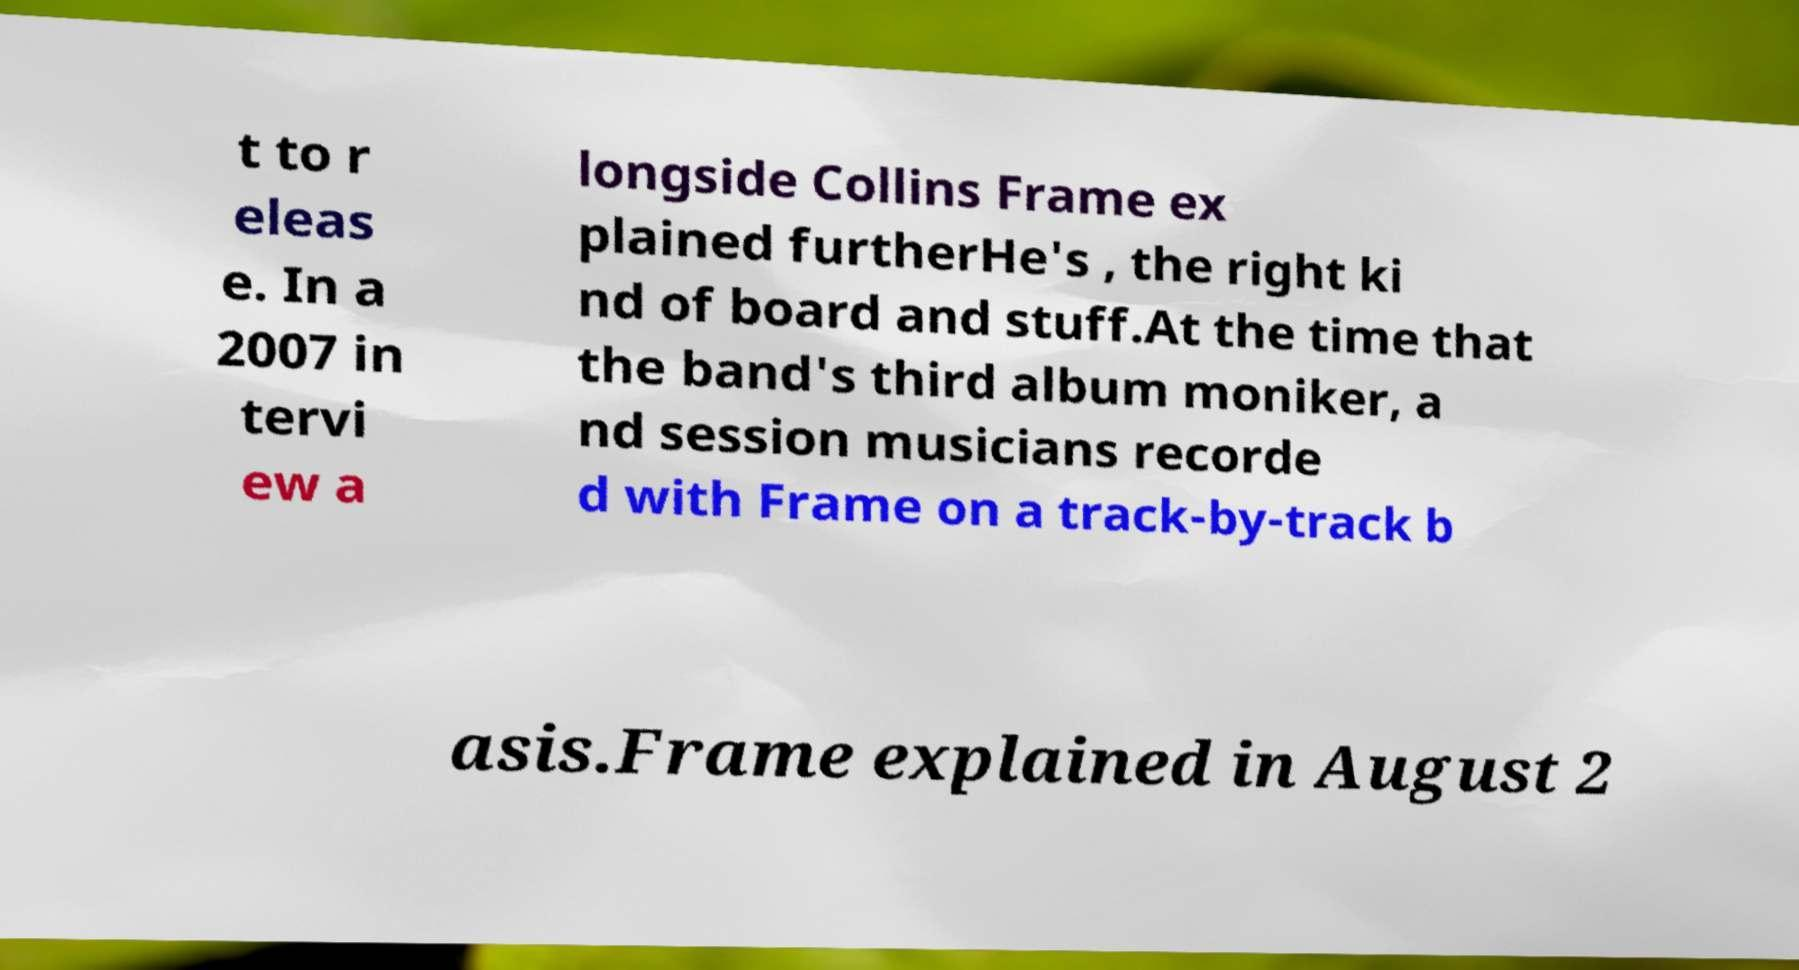Please read and relay the text visible in this image. What does it say? t to r eleas e. In a 2007 in tervi ew a longside Collins Frame ex plained furtherHe's , the right ki nd of board and stuff.At the time that the band's third album moniker, a nd session musicians recorde d with Frame on a track-by-track b asis.Frame explained in August 2 